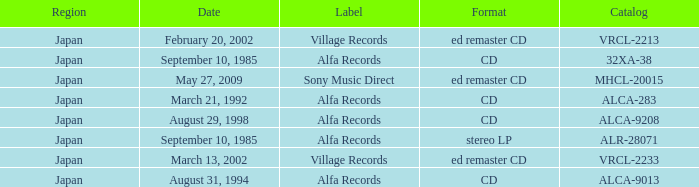Which Catalog was formated as a CD under the label Alfa Records? 32XA-38, ALCA-283, ALCA-9013, ALCA-9208. 